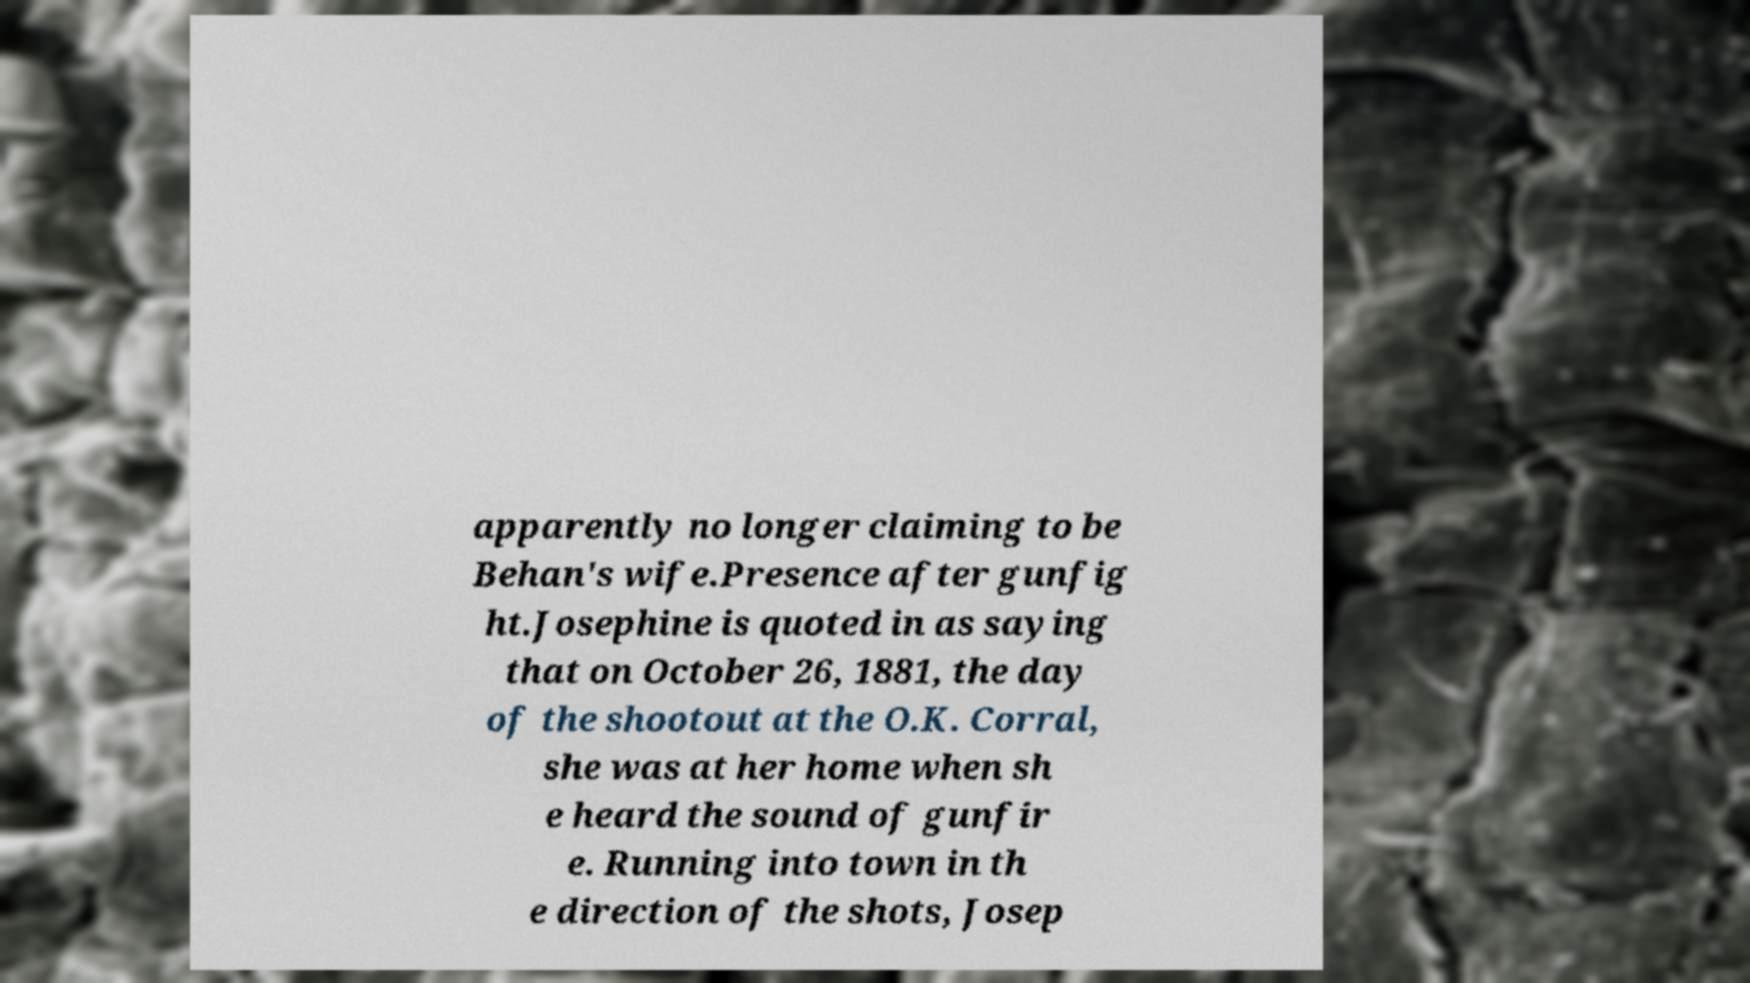Can you accurately transcribe the text from the provided image for me? apparently no longer claiming to be Behan's wife.Presence after gunfig ht.Josephine is quoted in as saying that on October 26, 1881, the day of the shootout at the O.K. Corral, she was at her home when sh e heard the sound of gunfir e. Running into town in th e direction of the shots, Josep 